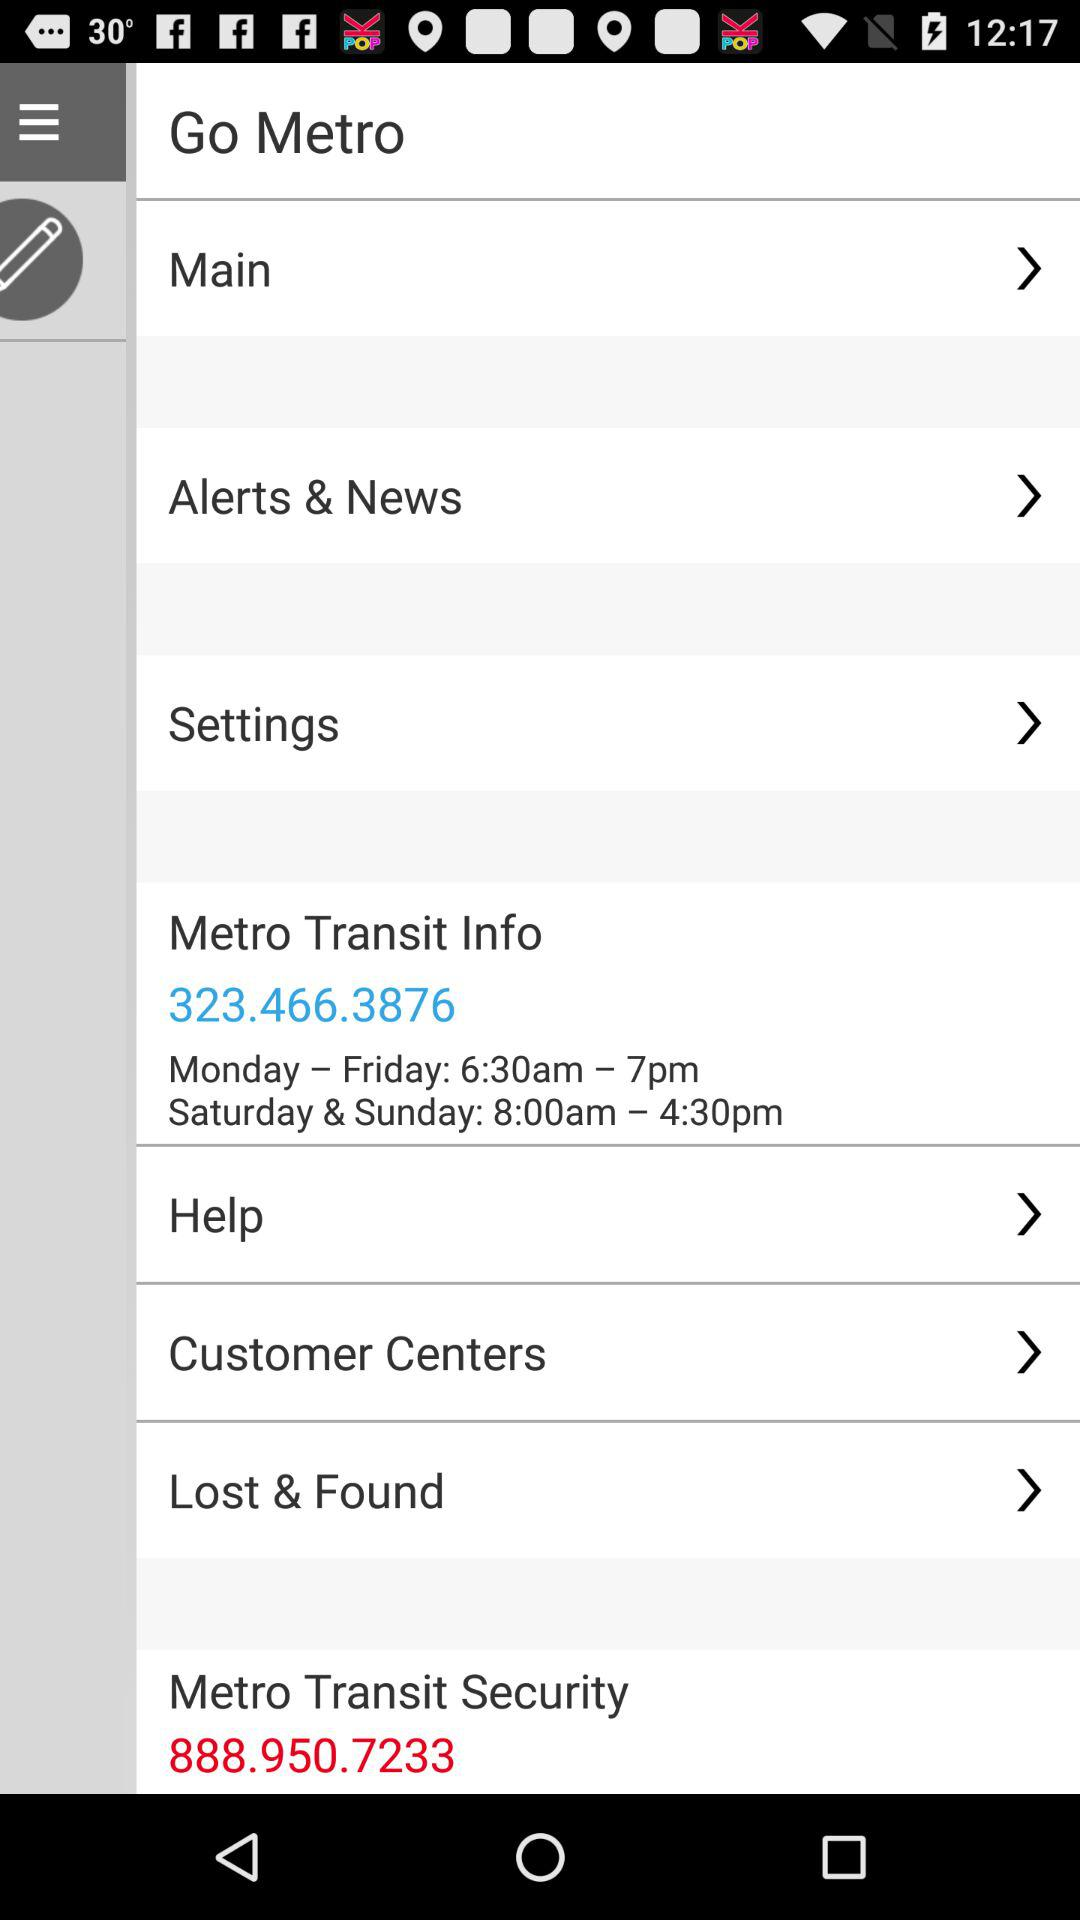What is the information contact number? The contact number is 323.466.3876. 